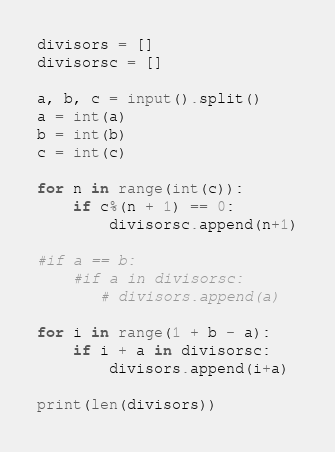Convert code to text. <code><loc_0><loc_0><loc_500><loc_500><_Python_>divisors = []
divisorsc = []

a, b, c = input().split()
a = int(a)
b = int(b)
c = int(c)

for n in range(int(c)):
    if c%(n + 1) == 0:
        divisorsc.append(n+1)

#if a == b:
    #if a in divisorsc:
       # divisors.append(a)
        
for i in range(1 + b - a):
    if i + a in divisorsc:
        divisors.append(i+a)
        
print(len(divisors))</code> 